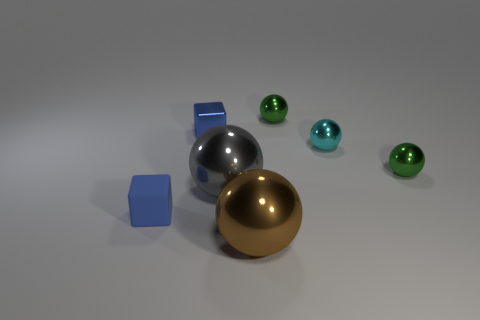There is a block that is to the left of the tiny blue block behind the blue object that is in front of the tiny blue metallic block; what size is it?
Provide a succinct answer. Small. The cyan metallic object has what size?
Your answer should be very brief. Small. Does the blue object that is behind the gray sphere have the same size as the brown metal sphere?
Provide a succinct answer. No. What number of small blue blocks are right of the cyan metal ball?
Ensure brevity in your answer.  0. Is the number of tiny blue rubber cubes in front of the small blue matte thing the same as the number of big red shiny blocks?
Ensure brevity in your answer.  Yes. What is the size of the thing that is to the right of the big gray metallic sphere and in front of the large gray ball?
Provide a short and direct response. Large. How many cyan shiny things have the same size as the rubber thing?
Your answer should be compact. 1. There is a metallic object in front of the big object that is behind the blue rubber block; what size is it?
Keep it short and to the point. Large. There is a small thing that is in front of the gray shiny object; is it the same shape as the tiny green metal thing that is in front of the tiny metal block?
Your answer should be very brief. No. There is a tiny object that is to the left of the brown ball and to the right of the tiny blue rubber thing; what is its color?
Provide a succinct answer. Blue. 